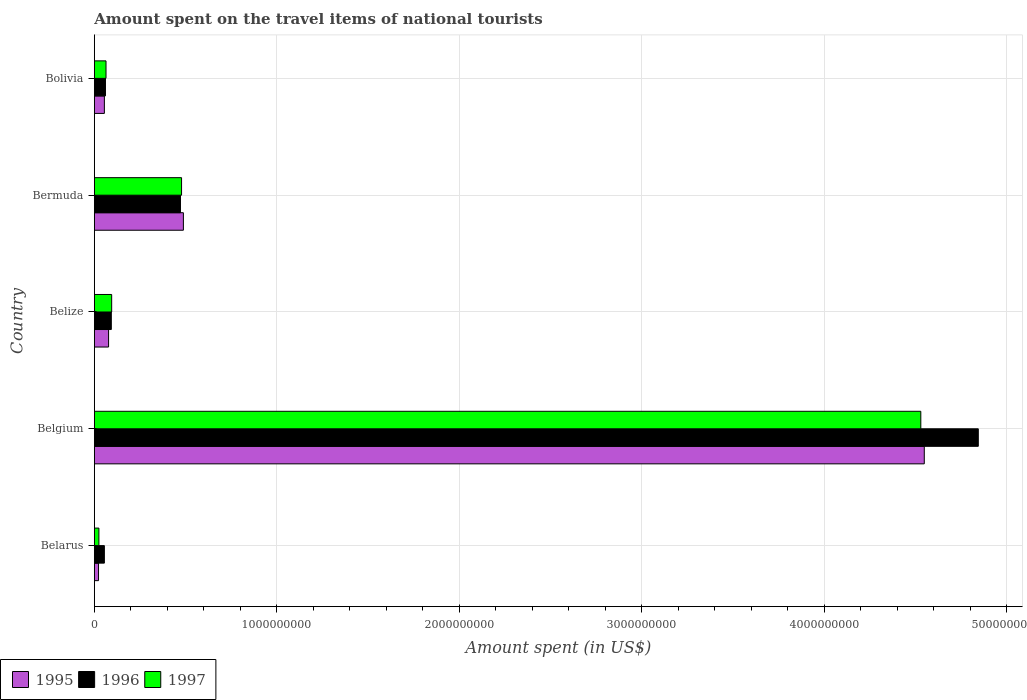Are the number of bars per tick equal to the number of legend labels?
Your response must be concise. Yes. Are the number of bars on each tick of the Y-axis equal?
Make the answer very short. Yes. How many bars are there on the 3rd tick from the bottom?
Offer a terse response. 3. What is the label of the 5th group of bars from the top?
Ensure brevity in your answer.  Belarus. In how many cases, is the number of bars for a given country not equal to the number of legend labels?
Offer a terse response. 0. What is the amount spent on the travel items of national tourists in 1996 in Bolivia?
Provide a short and direct response. 6.10e+07. Across all countries, what is the maximum amount spent on the travel items of national tourists in 1997?
Keep it short and to the point. 4.53e+09. Across all countries, what is the minimum amount spent on the travel items of national tourists in 1996?
Make the answer very short. 5.50e+07. In which country was the amount spent on the travel items of national tourists in 1997 minimum?
Provide a short and direct response. Belarus. What is the total amount spent on the travel items of national tourists in 1996 in the graph?
Your answer should be compact. 5.52e+09. What is the difference between the amount spent on the travel items of national tourists in 1997 in Bermuda and that in Bolivia?
Ensure brevity in your answer.  4.14e+08. What is the difference between the amount spent on the travel items of national tourists in 1995 in Bolivia and the amount spent on the travel items of national tourists in 1997 in Belize?
Keep it short and to the point. -4.00e+07. What is the average amount spent on the travel items of national tourists in 1996 per country?
Offer a terse response. 1.10e+09. In how many countries, is the amount spent on the travel items of national tourists in 1996 greater than 2400000000 US$?
Offer a terse response. 1. What is the ratio of the amount spent on the travel items of national tourists in 1996 in Bermuda to that in Bolivia?
Make the answer very short. 7.74. Is the amount spent on the travel items of national tourists in 1997 in Belarus less than that in Belize?
Offer a terse response. Yes. Is the difference between the amount spent on the travel items of national tourists in 1996 in Bermuda and Bolivia greater than the difference between the amount spent on the travel items of national tourists in 1997 in Bermuda and Bolivia?
Make the answer very short. No. What is the difference between the highest and the second highest amount spent on the travel items of national tourists in 1997?
Your response must be concise. 4.05e+09. What is the difference between the highest and the lowest amount spent on the travel items of national tourists in 1997?
Offer a very short reply. 4.50e+09. In how many countries, is the amount spent on the travel items of national tourists in 1997 greater than the average amount spent on the travel items of national tourists in 1997 taken over all countries?
Your answer should be very brief. 1. Is the sum of the amount spent on the travel items of national tourists in 1997 in Belarus and Bolivia greater than the maximum amount spent on the travel items of national tourists in 1996 across all countries?
Your answer should be compact. No. How many bars are there?
Provide a succinct answer. 15. Are all the bars in the graph horizontal?
Offer a very short reply. Yes. How many countries are there in the graph?
Your answer should be compact. 5. Are the values on the major ticks of X-axis written in scientific E-notation?
Your answer should be compact. No. Does the graph contain any zero values?
Provide a short and direct response. No. How many legend labels are there?
Offer a very short reply. 3. How are the legend labels stacked?
Offer a very short reply. Horizontal. What is the title of the graph?
Give a very brief answer. Amount spent on the travel items of national tourists. What is the label or title of the X-axis?
Offer a terse response. Amount spent (in US$). What is the label or title of the Y-axis?
Offer a terse response. Country. What is the Amount spent (in US$) of 1995 in Belarus?
Provide a succinct answer. 2.30e+07. What is the Amount spent (in US$) in 1996 in Belarus?
Make the answer very short. 5.50e+07. What is the Amount spent (in US$) in 1997 in Belarus?
Your response must be concise. 2.50e+07. What is the Amount spent (in US$) of 1995 in Belgium?
Your response must be concise. 4.55e+09. What is the Amount spent (in US$) of 1996 in Belgium?
Make the answer very short. 4.84e+09. What is the Amount spent (in US$) of 1997 in Belgium?
Provide a short and direct response. 4.53e+09. What is the Amount spent (in US$) of 1995 in Belize?
Your response must be concise. 7.80e+07. What is the Amount spent (in US$) of 1996 in Belize?
Ensure brevity in your answer.  9.30e+07. What is the Amount spent (in US$) in 1997 in Belize?
Your answer should be very brief. 9.50e+07. What is the Amount spent (in US$) in 1995 in Bermuda?
Offer a terse response. 4.88e+08. What is the Amount spent (in US$) of 1996 in Bermuda?
Provide a short and direct response. 4.72e+08. What is the Amount spent (in US$) in 1997 in Bermuda?
Provide a short and direct response. 4.78e+08. What is the Amount spent (in US$) of 1995 in Bolivia?
Provide a short and direct response. 5.50e+07. What is the Amount spent (in US$) in 1996 in Bolivia?
Give a very brief answer. 6.10e+07. What is the Amount spent (in US$) in 1997 in Bolivia?
Give a very brief answer. 6.40e+07. Across all countries, what is the maximum Amount spent (in US$) of 1995?
Offer a terse response. 4.55e+09. Across all countries, what is the maximum Amount spent (in US$) of 1996?
Provide a succinct answer. 4.84e+09. Across all countries, what is the maximum Amount spent (in US$) in 1997?
Keep it short and to the point. 4.53e+09. Across all countries, what is the minimum Amount spent (in US$) of 1995?
Give a very brief answer. 2.30e+07. Across all countries, what is the minimum Amount spent (in US$) of 1996?
Your response must be concise. 5.50e+07. Across all countries, what is the minimum Amount spent (in US$) of 1997?
Give a very brief answer. 2.50e+07. What is the total Amount spent (in US$) of 1995 in the graph?
Keep it short and to the point. 5.19e+09. What is the total Amount spent (in US$) in 1996 in the graph?
Offer a terse response. 5.52e+09. What is the total Amount spent (in US$) in 1997 in the graph?
Provide a short and direct response. 5.19e+09. What is the difference between the Amount spent (in US$) in 1995 in Belarus and that in Belgium?
Make the answer very short. -4.52e+09. What is the difference between the Amount spent (in US$) of 1996 in Belarus and that in Belgium?
Give a very brief answer. -4.79e+09. What is the difference between the Amount spent (in US$) of 1997 in Belarus and that in Belgium?
Provide a short and direct response. -4.50e+09. What is the difference between the Amount spent (in US$) in 1995 in Belarus and that in Belize?
Keep it short and to the point. -5.50e+07. What is the difference between the Amount spent (in US$) of 1996 in Belarus and that in Belize?
Ensure brevity in your answer.  -3.80e+07. What is the difference between the Amount spent (in US$) in 1997 in Belarus and that in Belize?
Ensure brevity in your answer.  -7.00e+07. What is the difference between the Amount spent (in US$) of 1995 in Belarus and that in Bermuda?
Keep it short and to the point. -4.65e+08. What is the difference between the Amount spent (in US$) of 1996 in Belarus and that in Bermuda?
Offer a very short reply. -4.17e+08. What is the difference between the Amount spent (in US$) in 1997 in Belarus and that in Bermuda?
Your response must be concise. -4.53e+08. What is the difference between the Amount spent (in US$) of 1995 in Belarus and that in Bolivia?
Keep it short and to the point. -3.20e+07. What is the difference between the Amount spent (in US$) in 1996 in Belarus and that in Bolivia?
Keep it short and to the point. -6.00e+06. What is the difference between the Amount spent (in US$) in 1997 in Belarus and that in Bolivia?
Give a very brief answer. -3.90e+07. What is the difference between the Amount spent (in US$) in 1995 in Belgium and that in Belize?
Your answer should be very brief. 4.47e+09. What is the difference between the Amount spent (in US$) in 1996 in Belgium and that in Belize?
Provide a short and direct response. 4.75e+09. What is the difference between the Amount spent (in US$) in 1997 in Belgium and that in Belize?
Provide a succinct answer. 4.43e+09. What is the difference between the Amount spent (in US$) in 1995 in Belgium and that in Bermuda?
Your response must be concise. 4.06e+09. What is the difference between the Amount spent (in US$) in 1996 in Belgium and that in Bermuda?
Give a very brief answer. 4.37e+09. What is the difference between the Amount spent (in US$) of 1997 in Belgium and that in Bermuda?
Your response must be concise. 4.05e+09. What is the difference between the Amount spent (in US$) in 1995 in Belgium and that in Bolivia?
Ensure brevity in your answer.  4.49e+09. What is the difference between the Amount spent (in US$) of 1996 in Belgium and that in Bolivia?
Your response must be concise. 4.78e+09. What is the difference between the Amount spent (in US$) of 1997 in Belgium and that in Bolivia?
Your answer should be compact. 4.46e+09. What is the difference between the Amount spent (in US$) in 1995 in Belize and that in Bermuda?
Your answer should be very brief. -4.10e+08. What is the difference between the Amount spent (in US$) of 1996 in Belize and that in Bermuda?
Give a very brief answer. -3.79e+08. What is the difference between the Amount spent (in US$) of 1997 in Belize and that in Bermuda?
Keep it short and to the point. -3.83e+08. What is the difference between the Amount spent (in US$) in 1995 in Belize and that in Bolivia?
Offer a terse response. 2.30e+07. What is the difference between the Amount spent (in US$) of 1996 in Belize and that in Bolivia?
Keep it short and to the point. 3.20e+07. What is the difference between the Amount spent (in US$) in 1997 in Belize and that in Bolivia?
Your answer should be compact. 3.10e+07. What is the difference between the Amount spent (in US$) in 1995 in Bermuda and that in Bolivia?
Your response must be concise. 4.33e+08. What is the difference between the Amount spent (in US$) of 1996 in Bermuda and that in Bolivia?
Offer a terse response. 4.11e+08. What is the difference between the Amount spent (in US$) in 1997 in Bermuda and that in Bolivia?
Provide a succinct answer. 4.14e+08. What is the difference between the Amount spent (in US$) of 1995 in Belarus and the Amount spent (in US$) of 1996 in Belgium?
Give a very brief answer. -4.82e+09. What is the difference between the Amount spent (in US$) in 1995 in Belarus and the Amount spent (in US$) in 1997 in Belgium?
Your answer should be very brief. -4.51e+09. What is the difference between the Amount spent (in US$) of 1996 in Belarus and the Amount spent (in US$) of 1997 in Belgium?
Keep it short and to the point. -4.47e+09. What is the difference between the Amount spent (in US$) of 1995 in Belarus and the Amount spent (in US$) of 1996 in Belize?
Offer a very short reply. -7.00e+07. What is the difference between the Amount spent (in US$) in 1995 in Belarus and the Amount spent (in US$) in 1997 in Belize?
Make the answer very short. -7.20e+07. What is the difference between the Amount spent (in US$) in 1996 in Belarus and the Amount spent (in US$) in 1997 in Belize?
Provide a succinct answer. -4.00e+07. What is the difference between the Amount spent (in US$) in 1995 in Belarus and the Amount spent (in US$) in 1996 in Bermuda?
Offer a very short reply. -4.49e+08. What is the difference between the Amount spent (in US$) of 1995 in Belarus and the Amount spent (in US$) of 1997 in Bermuda?
Provide a succinct answer. -4.55e+08. What is the difference between the Amount spent (in US$) of 1996 in Belarus and the Amount spent (in US$) of 1997 in Bermuda?
Offer a terse response. -4.23e+08. What is the difference between the Amount spent (in US$) in 1995 in Belarus and the Amount spent (in US$) in 1996 in Bolivia?
Ensure brevity in your answer.  -3.80e+07. What is the difference between the Amount spent (in US$) in 1995 in Belarus and the Amount spent (in US$) in 1997 in Bolivia?
Your answer should be compact. -4.10e+07. What is the difference between the Amount spent (in US$) in 1996 in Belarus and the Amount spent (in US$) in 1997 in Bolivia?
Offer a very short reply. -9.00e+06. What is the difference between the Amount spent (in US$) of 1995 in Belgium and the Amount spent (in US$) of 1996 in Belize?
Keep it short and to the point. 4.46e+09. What is the difference between the Amount spent (in US$) of 1995 in Belgium and the Amount spent (in US$) of 1997 in Belize?
Ensure brevity in your answer.  4.45e+09. What is the difference between the Amount spent (in US$) of 1996 in Belgium and the Amount spent (in US$) of 1997 in Belize?
Ensure brevity in your answer.  4.75e+09. What is the difference between the Amount spent (in US$) in 1995 in Belgium and the Amount spent (in US$) in 1996 in Bermuda?
Give a very brief answer. 4.08e+09. What is the difference between the Amount spent (in US$) of 1995 in Belgium and the Amount spent (in US$) of 1997 in Bermuda?
Provide a short and direct response. 4.07e+09. What is the difference between the Amount spent (in US$) of 1996 in Belgium and the Amount spent (in US$) of 1997 in Bermuda?
Keep it short and to the point. 4.37e+09. What is the difference between the Amount spent (in US$) in 1995 in Belgium and the Amount spent (in US$) in 1996 in Bolivia?
Provide a short and direct response. 4.49e+09. What is the difference between the Amount spent (in US$) of 1995 in Belgium and the Amount spent (in US$) of 1997 in Bolivia?
Offer a very short reply. 4.48e+09. What is the difference between the Amount spent (in US$) of 1996 in Belgium and the Amount spent (in US$) of 1997 in Bolivia?
Offer a terse response. 4.78e+09. What is the difference between the Amount spent (in US$) in 1995 in Belize and the Amount spent (in US$) in 1996 in Bermuda?
Make the answer very short. -3.94e+08. What is the difference between the Amount spent (in US$) of 1995 in Belize and the Amount spent (in US$) of 1997 in Bermuda?
Provide a succinct answer. -4.00e+08. What is the difference between the Amount spent (in US$) in 1996 in Belize and the Amount spent (in US$) in 1997 in Bermuda?
Provide a short and direct response. -3.85e+08. What is the difference between the Amount spent (in US$) in 1995 in Belize and the Amount spent (in US$) in 1996 in Bolivia?
Make the answer very short. 1.70e+07. What is the difference between the Amount spent (in US$) in 1995 in Belize and the Amount spent (in US$) in 1997 in Bolivia?
Offer a terse response. 1.40e+07. What is the difference between the Amount spent (in US$) of 1996 in Belize and the Amount spent (in US$) of 1997 in Bolivia?
Give a very brief answer. 2.90e+07. What is the difference between the Amount spent (in US$) of 1995 in Bermuda and the Amount spent (in US$) of 1996 in Bolivia?
Provide a succinct answer. 4.27e+08. What is the difference between the Amount spent (in US$) in 1995 in Bermuda and the Amount spent (in US$) in 1997 in Bolivia?
Your answer should be compact. 4.24e+08. What is the difference between the Amount spent (in US$) of 1996 in Bermuda and the Amount spent (in US$) of 1997 in Bolivia?
Your answer should be compact. 4.08e+08. What is the average Amount spent (in US$) of 1995 per country?
Your answer should be compact. 1.04e+09. What is the average Amount spent (in US$) in 1996 per country?
Provide a short and direct response. 1.10e+09. What is the average Amount spent (in US$) of 1997 per country?
Provide a short and direct response. 1.04e+09. What is the difference between the Amount spent (in US$) of 1995 and Amount spent (in US$) of 1996 in Belarus?
Offer a terse response. -3.20e+07. What is the difference between the Amount spent (in US$) of 1995 and Amount spent (in US$) of 1997 in Belarus?
Keep it short and to the point. -2.00e+06. What is the difference between the Amount spent (in US$) in 1996 and Amount spent (in US$) in 1997 in Belarus?
Ensure brevity in your answer.  3.00e+07. What is the difference between the Amount spent (in US$) of 1995 and Amount spent (in US$) of 1996 in Belgium?
Give a very brief answer. -2.96e+08. What is the difference between the Amount spent (in US$) of 1995 and Amount spent (in US$) of 1997 in Belgium?
Give a very brief answer. 1.90e+07. What is the difference between the Amount spent (in US$) in 1996 and Amount spent (in US$) in 1997 in Belgium?
Your response must be concise. 3.15e+08. What is the difference between the Amount spent (in US$) of 1995 and Amount spent (in US$) of 1996 in Belize?
Ensure brevity in your answer.  -1.50e+07. What is the difference between the Amount spent (in US$) of 1995 and Amount spent (in US$) of 1997 in Belize?
Offer a very short reply. -1.70e+07. What is the difference between the Amount spent (in US$) in 1995 and Amount spent (in US$) in 1996 in Bermuda?
Offer a terse response. 1.60e+07. What is the difference between the Amount spent (in US$) of 1996 and Amount spent (in US$) of 1997 in Bermuda?
Make the answer very short. -6.00e+06. What is the difference between the Amount spent (in US$) of 1995 and Amount spent (in US$) of 1996 in Bolivia?
Provide a succinct answer. -6.00e+06. What is the difference between the Amount spent (in US$) of 1995 and Amount spent (in US$) of 1997 in Bolivia?
Your answer should be very brief. -9.00e+06. What is the ratio of the Amount spent (in US$) in 1995 in Belarus to that in Belgium?
Make the answer very short. 0.01. What is the ratio of the Amount spent (in US$) of 1996 in Belarus to that in Belgium?
Provide a short and direct response. 0.01. What is the ratio of the Amount spent (in US$) in 1997 in Belarus to that in Belgium?
Your response must be concise. 0.01. What is the ratio of the Amount spent (in US$) of 1995 in Belarus to that in Belize?
Offer a very short reply. 0.29. What is the ratio of the Amount spent (in US$) in 1996 in Belarus to that in Belize?
Offer a terse response. 0.59. What is the ratio of the Amount spent (in US$) of 1997 in Belarus to that in Belize?
Offer a terse response. 0.26. What is the ratio of the Amount spent (in US$) in 1995 in Belarus to that in Bermuda?
Your answer should be very brief. 0.05. What is the ratio of the Amount spent (in US$) in 1996 in Belarus to that in Bermuda?
Your answer should be very brief. 0.12. What is the ratio of the Amount spent (in US$) of 1997 in Belarus to that in Bermuda?
Offer a terse response. 0.05. What is the ratio of the Amount spent (in US$) in 1995 in Belarus to that in Bolivia?
Provide a succinct answer. 0.42. What is the ratio of the Amount spent (in US$) of 1996 in Belarus to that in Bolivia?
Your response must be concise. 0.9. What is the ratio of the Amount spent (in US$) in 1997 in Belarus to that in Bolivia?
Your response must be concise. 0.39. What is the ratio of the Amount spent (in US$) in 1995 in Belgium to that in Belize?
Your answer should be compact. 58.31. What is the ratio of the Amount spent (in US$) of 1996 in Belgium to that in Belize?
Ensure brevity in your answer.  52.09. What is the ratio of the Amount spent (in US$) of 1997 in Belgium to that in Belize?
Make the answer very short. 47.67. What is the ratio of the Amount spent (in US$) in 1995 in Belgium to that in Bermuda?
Offer a terse response. 9.32. What is the ratio of the Amount spent (in US$) of 1996 in Belgium to that in Bermuda?
Offer a very short reply. 10.26. What is the ratio of the Amount spent (in US$) of 1997 in Belgium to that in Bermuda?
Keep it short and to the point. 9.47. What is the ratio of the Amount spent (in US$) in 1995 in Belgium to that in Bolivia?
Your answer should be compact. 82.69. What is the ratio of the Amount spent (in US$) in 1996 in Belgium to that in Bolivia?
Keep it short and to the point. 79.41. What is the ratio of the Amount spent (in US$) in 1997 in Belgium to that in Bolivia?
Offer a terse response. 70.77. What is the ratio of the Amount spent (in US$) in 1995 in Belize to that in Bermuda?
Your answer should be compact. 0.16. What is the ratio of the Amount spent (in US$) of 1996 in Belize to that in Bermuda?
Offer a very short reply. 0.2. What is the ratio of the Amount spent (in US$) in 1997 in Belize to that in Bermuda?
Provide a short and direct response. 0.2. What is the ratio of the Amount spent (in US$) of 1995 in Belize to that in Bolivia?
Provide a succinct answer. 1.42. What is the ratio of the Amount spent (in US$) of 1996 in Belize to that in Bolivia?
Offer a terse response. 1.52. What is the ratio of the Amount spent (in US$) in 1997 in Belize to that in Bolivia?
Provide a succinct answer. 1.48. What is the ratio of the Amount spent (in US$) of 1995 in Bermuda to that in Bolivia?
Keep it short and to the point. 8.87. What is the ratio of the Amount spent (in US$) of 1996 in Bermuda to that in Bolivia?
Ensure brevity in your answer.  7.74. What is the ratio of the Amount spent (in US$) in 1997 in Bermuda to that in Bolivia?
Your answer should be compact. 7.47. What is the difference between the highest and the second highest Amount spent (in US$) of 1995?
Ensure brevity in your answer.  4.06e+09. What is the difference between the highest and the second highest Amount spent (in US$) of 1996?
Your answer should be compact. 4.37e+09. What is the difference between the highest and the second highest Amount spent (in US$) in 1997?
Provide a succinct answer. 4.05e+09. What is the difference between the highest and the lowest Amount spent (in US$) in 1995?
Your answer should be compact. 4.52e+09. What is the difference between the highest and the lowest Amount spent (in US$) of 1996?
Keep it short and to the point. 4.79e+09. What is the difference between the highest and the lowest Amount spent (in US$) of 1997?
Provide a succinct answer. 4.50e+09. 